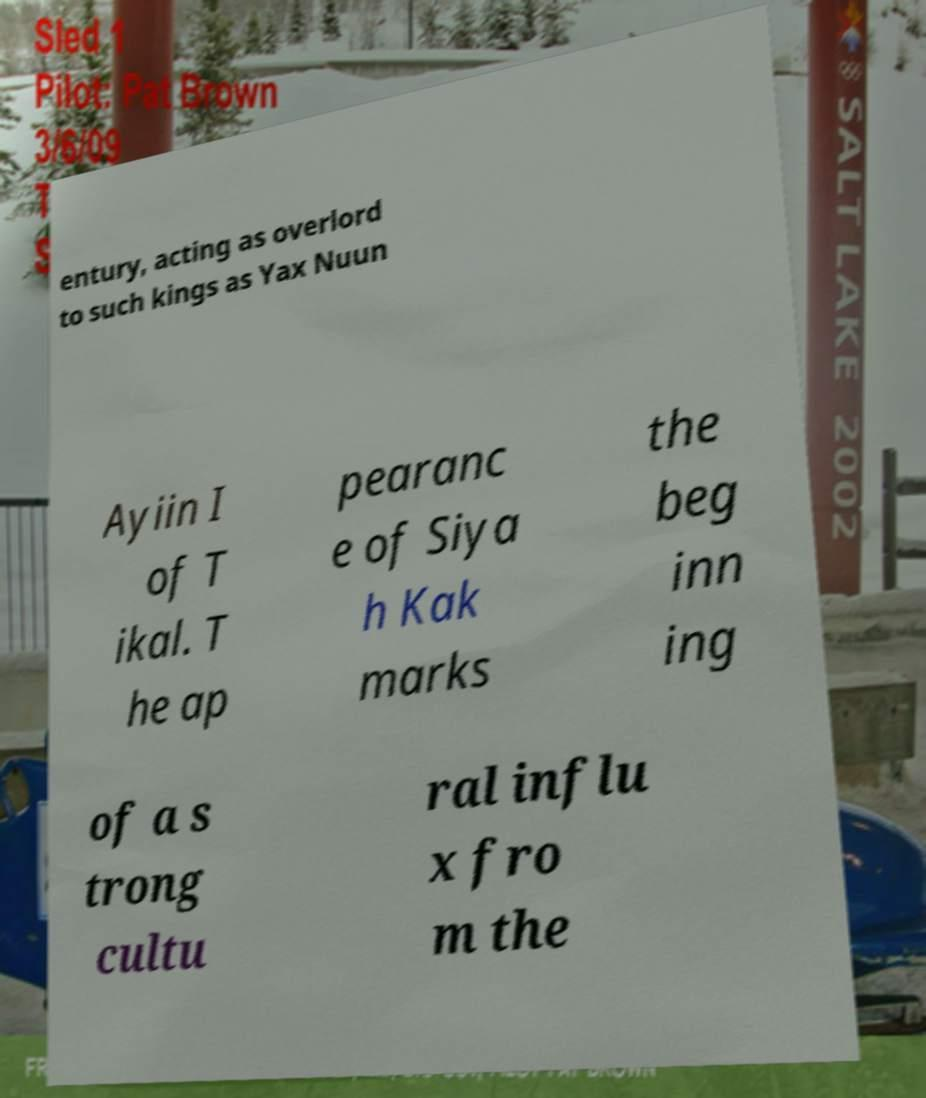Can you accurately transcribe the text from the provided image for me? entury, acting as overlord to such kings as Yax Nuun Ayiin I of T ikal. T he ap pearanc e of Siya h Kak marks the beg inn ing of a s trong cultu ral influ x fro m the 